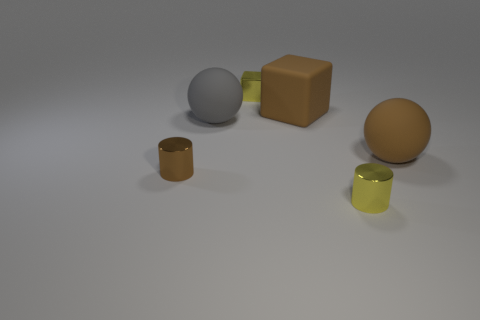There is a tiny object that is the same color as the big rubber cube; what is it made of?
Your answer should be very brief. Metal. What number of things are either big brown cubes or gray things?
Your answer should be very brief. 2. There is a metal cylinder that is on the right side of the gray sphere; does it have the same size as the large cube?
Your response must be concise. No. What is the size of the metallic object that is right of the tiny brown metal thing and in front of the brown rubber sphere?
Offer a terse response. Small. How many other things are the same shape as the small brown thing?
Your answer should be compact. 1. There is another object that is the same shape as the gray object; what is its size?
Your answer should be compact. Large. Do the small shiny block and the large rubber cube have the same color?
Make the answer very short. No. The object that is both behind the brown shiny object and left of the tiny block is what color?
Provide a succinct answer. Gray. How many objects are either rubber spheres to the right of the large gray rubber ball or large spheres?
Offer a very short reply. 2. What color is the other rubber object that is the same shape as the gray rubber object?
Provide a short and direct response. Brown. 